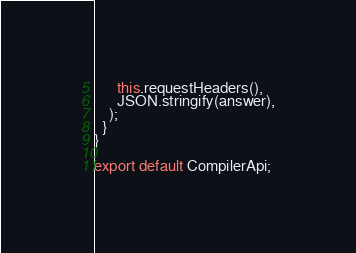<code> <loc_0><loc_0><loc_500><loc_500><_JavaScript_>      this.requestHeaders(),
      JSON.stringify(answer),
    );
  }
}

export default CompilerApi;
</code> 